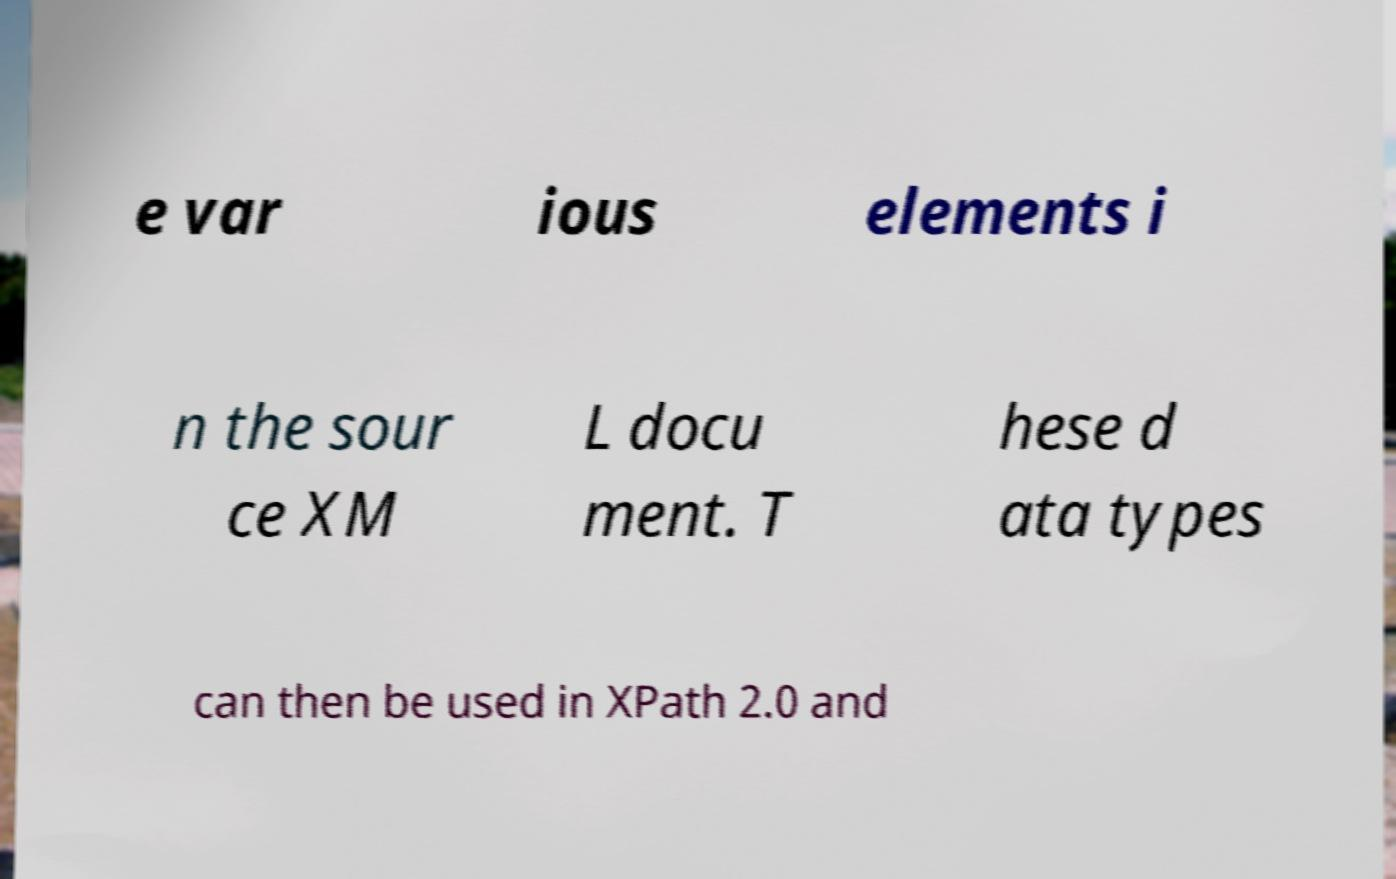Can you accurately transcribe the text from the provided image for me? e var ious elements i n the sour ce XM L docu ment. T hese d ata types can then be used in XPath 2.0 and 